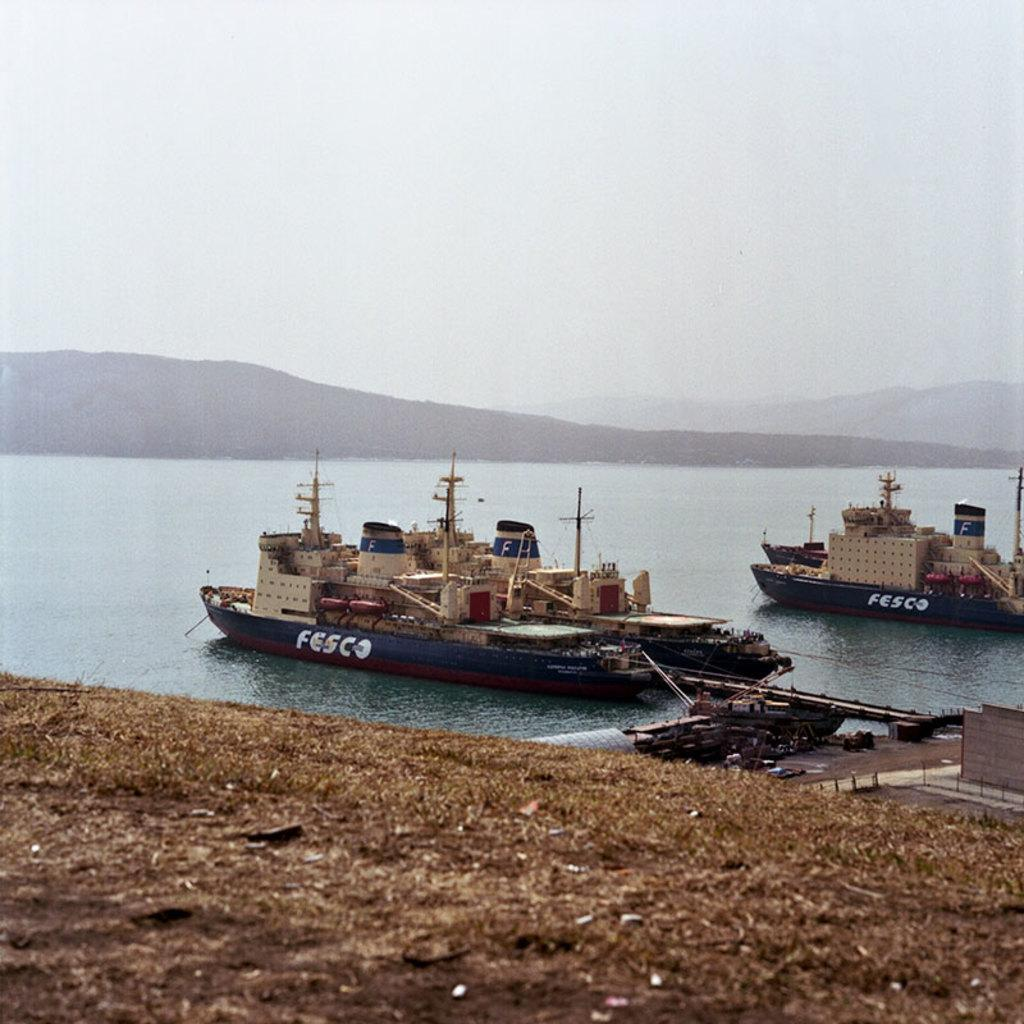<image>
Write a terse but informative summary of the picture. a fesco boat that is on the water outside 